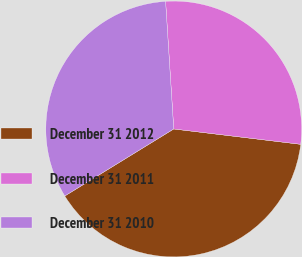Convert chart to OTSL. <chart><loc_0><loc_0><loc_500><loc_500><pie_chart><fcel>December 31 2012<fcel>December 31 2011<fcel>December 31 2010<nl><fcel>39.31%<fcel>27.93%<fcel>32.76%<nl></chart> 